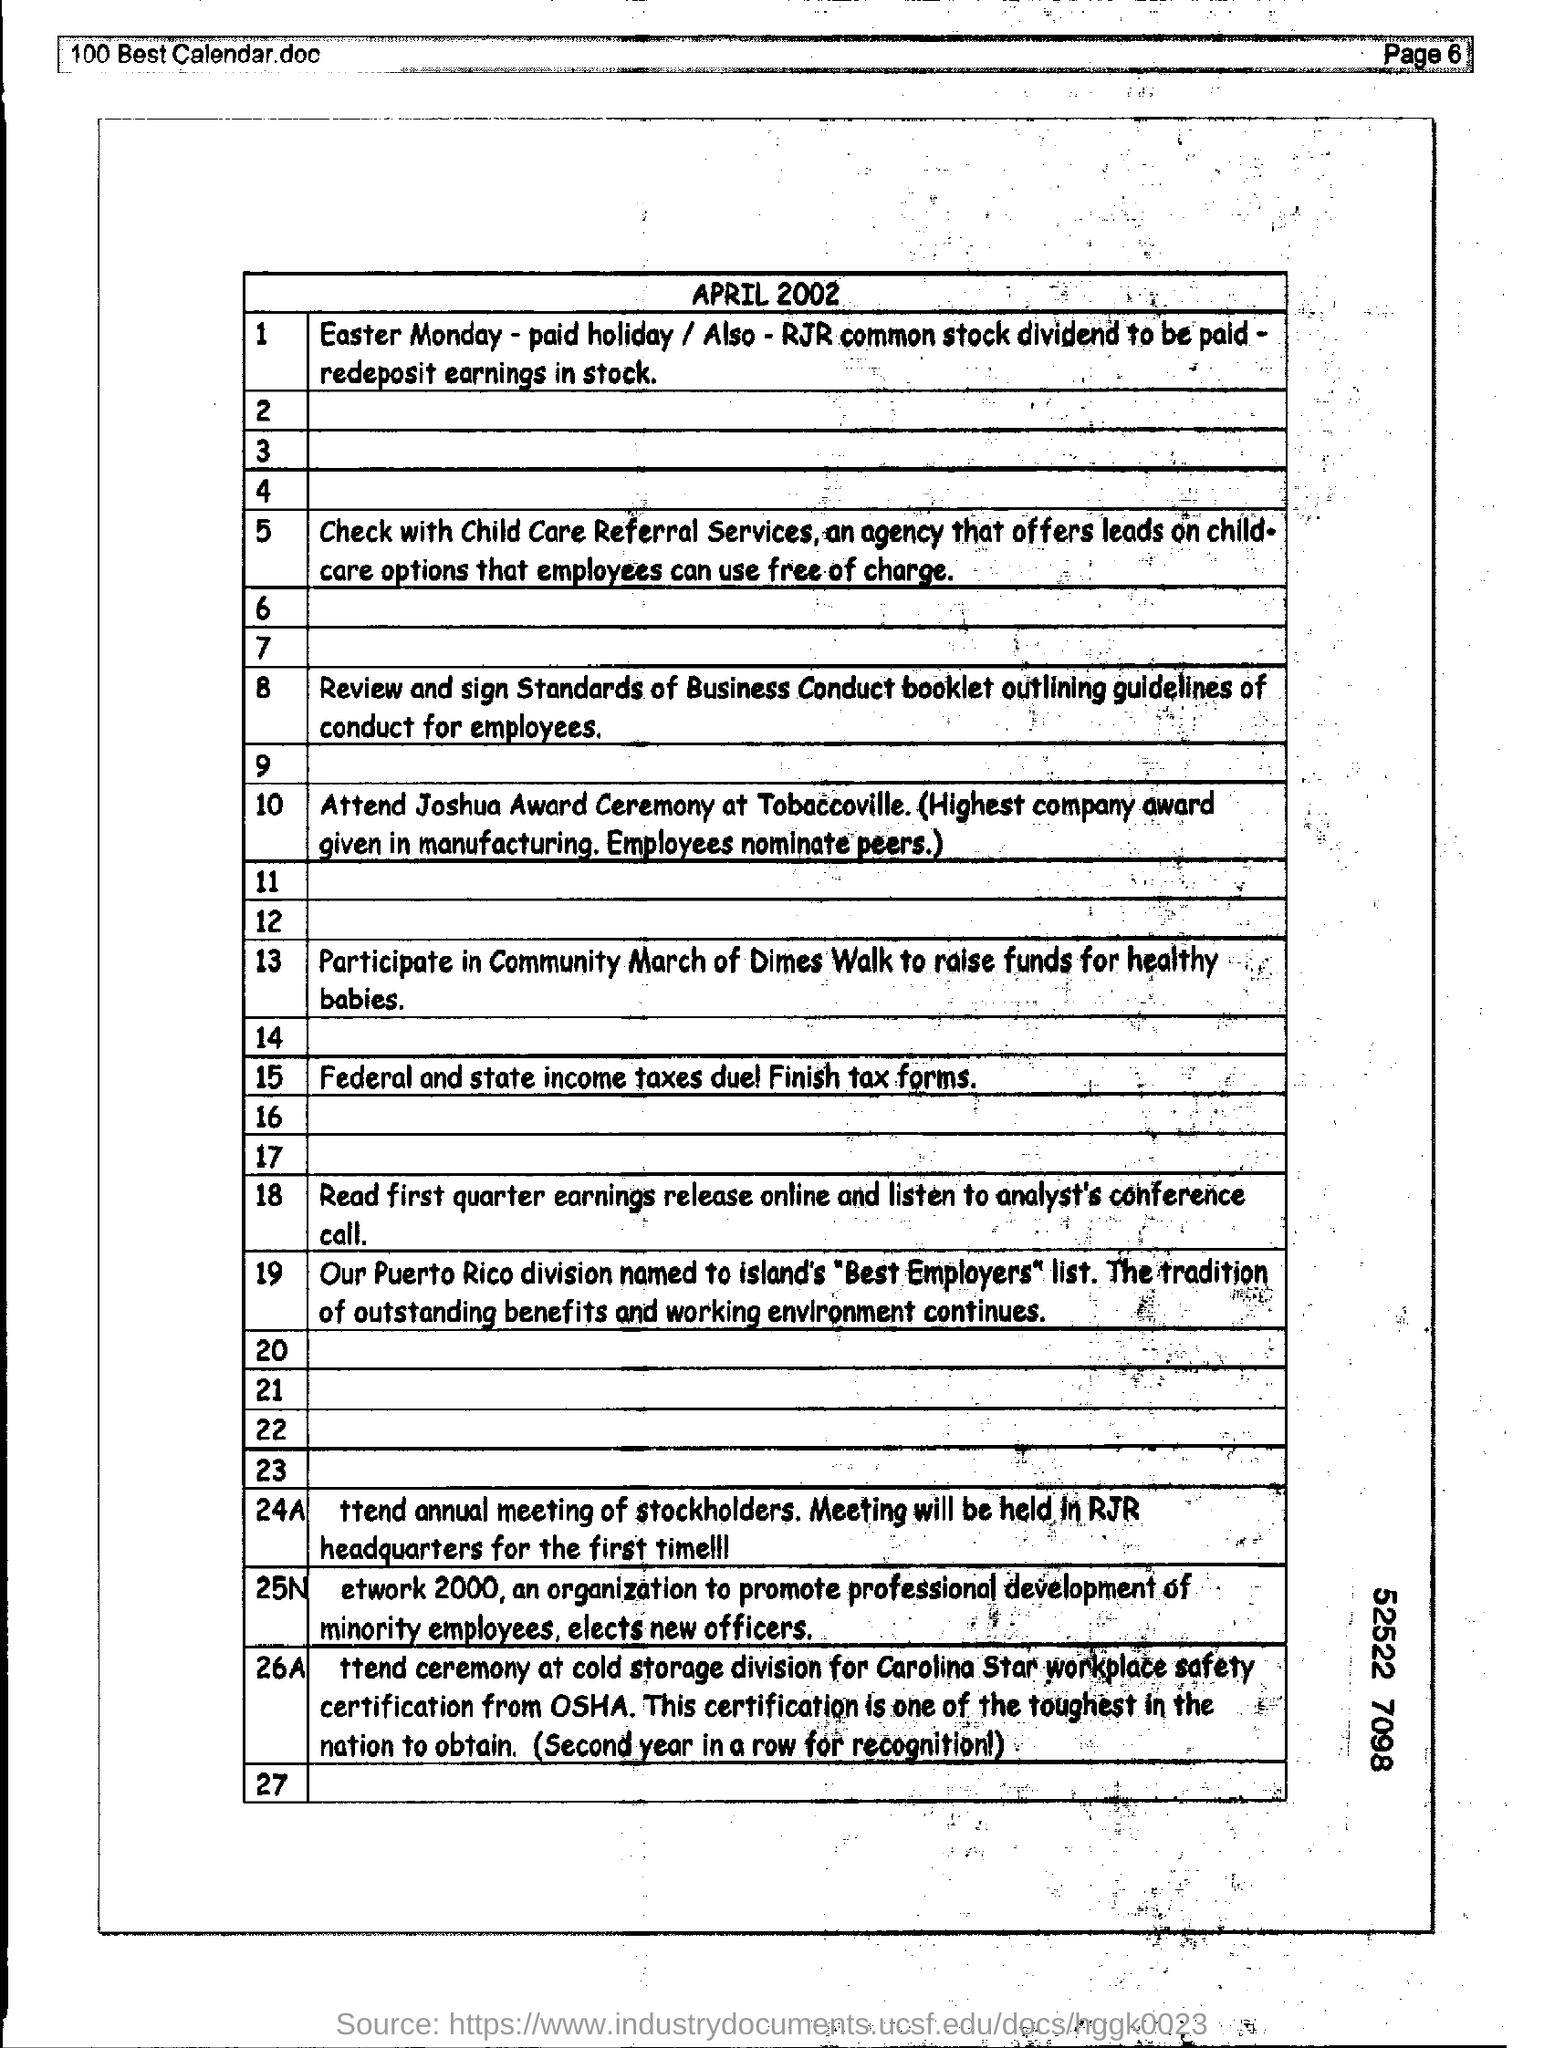Highlight a few significant elements in this photo. Please include a mention of the page number at the top right corner of the page as indicated on page 6. 